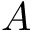Convert formula to latex. <formula><loc_0><loc_0><loc_500><loc_500>A</formula> 